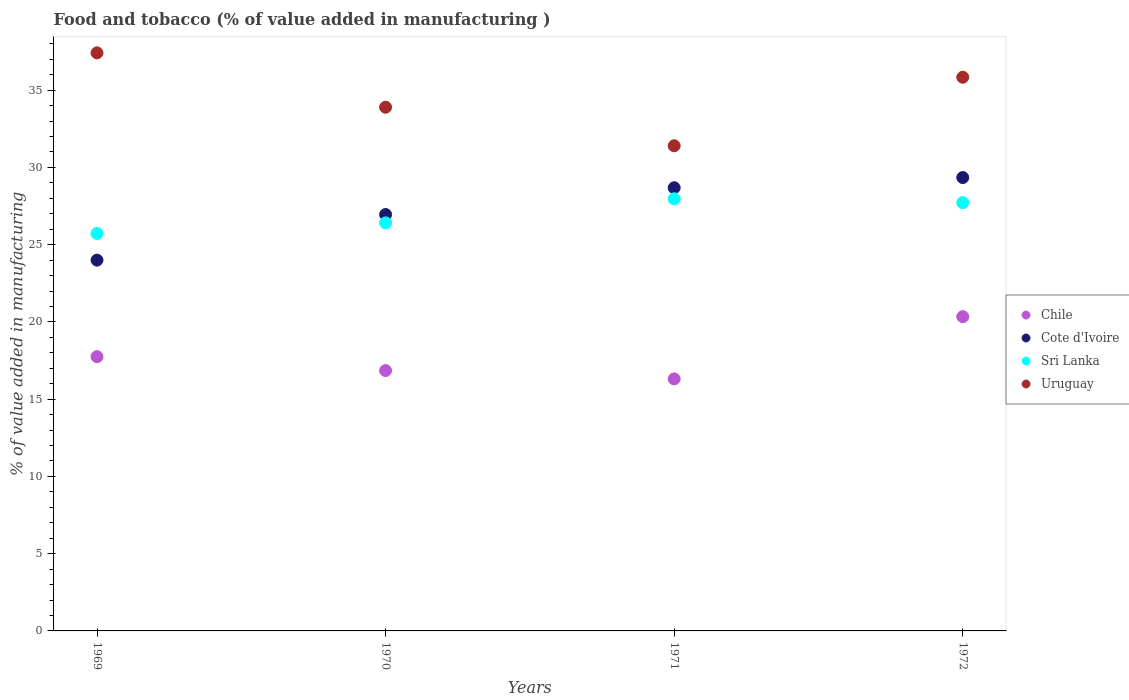What is the value added in manufacturing food and tobacco in Uruguay in 1970?
Provide a succinct answer. 33.9. Across all years, what is the maximum value added in manufacturing food and tobacco in Chile?
Your answer should be compact. 20.34. Across all years, what is the minimum value added in manufacturing food and tobacco in Uruguay?
Offer a terse response. 31.4. In which year was the value added in manufacturing food and tobacco in Sri Lanka minimum?
Provide a succinct answer. 1969. What is the total value added in manufacturing food and tobacco in Sri Lanka in the graph?
Make the answer very short. 107.83. What is the difference between the value added in manufacturing food and tobacco in Cote d'Ivoire in 1969 and that in 1970?
Offer a very short reply. -2.95. What is the difference between the value added in manufacturing food and tobacco in Sri Lanka in 1971 and the value added in manufacturing food and tobacco in Chile in 1970?
Offer a terse response. 11.12. What is the average value added in manufacturing food and tobacco in Sri Lanka per year?
Give a very brief answer. 26.96. In the year 1969, what is the difference between the value added in manufacturing food and tobacco in Uruguay and value added in manufacturing food and tobacco in Sri Lanka?
Provide a succinct answer. 11.69. What is the ratio of the value added in manufacturing food and tobacco in Cote d'Ivoire in 1970 to that in 1972?
Provide a succinct answer. 0.92. Is the value added in manufacturing food and tobacco in Uruguay in 1970 less than that in 1972?
Offer a very short reply. Yes. What is the difference between the highest and the second highest value added in manufacturing food and tobacco in Uruguay?
Provide a short and direct response. 1.58. What is the difference between the highest and the lowest value added in manufacturing food and tobacco in Chile?
Ensure brevity in your answer.  4.03. Is the sum of the value added in manufacturing food and tobacco in Uruguay in 1971 and 1972 greater than the maximum value added in manufacturing food and tobacco in Cote d'Ivoire across all years?
Ensure brevity in your answer.  Yes. Is the value added in manufacturing food and tobacco in Uruguay strictly greater than the value added in manufacturing food and tobacco in Sri Lanka over the years?
Give a very brief answer. Yes. How many years are there in the graph?
Offer a terse response. 4. What is the difference between two consecutive major ticks on the Y-axis?
Offer a very short reply. 5. Does the graph contain grids?
Provide a succinct answer. No. How many legend labels are there?
Make the answer very short. 4. How are the legend labels stacked?
Make the answer very short. Vertical. What is the title of the graph?
Ensure brevity in your answer.  Food and tobacco (% of value added in manufacturing ). Does "Germany" appear as one of the legend labels in the graph?
Provide a succinct answer. No. What is the label or title of the Y-axis?
Your response must be concise. % of value added in manufacturing. What is the % of value added in manufacturing of Chile in 1969?
Your answer should be compact. 17.75. What is the % of value added in manufacturing of Cote d'Ivoire in 1969?
Offer a terse response. 24. What is the % of value added in manufacturing of Sri Lanka in 1969?
Your answer should be compact. 25.73. What is the % of value added in manufacturing of Uruguay in 1969?
Your answer should be very brief. 37.42. What is the % of value added in manufacturing in Chile in 1970?
Make the answer very short. 16.85. What is the % of value added in manufacturing in Cote d'Ivoire in 1970?
Offer a terse response. 26.95. What is the % of value added in manufacturing of Sri Lanka in 1970?
Give a very brief answer. 26.41. What is the % of value added in manufacturing of Uruguay in 1970?
Ensure brevity in your answer.  33.9. What is the % of value added in manufacturing in Chile in 1971?
Keep it short and to the point. 16.31. What is the % of value added in manufacturing in Cote d'Ivoire in 1971?
Provide a succinct answer. 28.69. What is the % of value added in manufacturing in Sri Lanka in 1971?
Give a very brief answer. 27.97. What is the % of value added in manufacturing in Uruguay in 1971?
Your answer should be very brief. 31.4. What is the % of value added in manufacturing of Chile in 1972?
Provide a succinct answer. 20.34. What is the % of value added in manufacturing of Cote d'Ivoire in 1972?
Provide a short and direct response. 29.34. What is the % of value added in manufacturing of Sri Lanka in 1972?
Offer a very short reply. 27.72. What is the % of value added in manufacturing of Uruguay in 1972?
Your response must be concise. 35.84. Across all years, what is the maximum % of value added in manufacturing in Chile?
Your answer should be compact. 20.34. Across all years, what is the maximum % of value added in manufacturing of Cote d'Ivoire?
Provide a short and direct response. 29.34. Across all years, what is the maximum % of value added in manufacturing of Sri Lanka?
Give a very brief answer. 27.97. Across all years, what is the maximum % of value added in manufacturing of Uruguay?
Your answer should be very brief. 37.42. Across all years, what is the minimum % of value added in manufacturing of Chile?
Offer a terse response. 16.31. Across all years, what is the minimum % of value added in manufacturing of Cote d'Ivoire?
Provide a succinct answer. 24. Across all years, what is the minimum % of value added in manufacturing in Sri Lanka?
Ensure brevity in your answer.  25.73. Across all years, what is the minimum % of value added in manufacturing of Uruguay?
Keep it short and to the point. 31.4. What is the total % of value added in manufacturing of Chile in the graph?
Give a very brief answer. 71.26. What is the total % of value added in manufacturing in Cote d'Ivoire in the graph?
Offer a very short reply. 108.99. What is the total % of value added in manufacturing of Sri Lanka in the graph?
Provide a short and direct response. 107.83. What is the total % of value added in manufacturing in Uruguay in the graph?
Give a very brief answer. 138.56. What is the difference between the % of value added in manufacturing of Chile in 1969 and that in 1970?
Ensure brevity in your answer.  0.9. What is the difference between the % of value added in manufacturing in Cote d'Ivoire in 1969 and that in 1970?
Offer a terse response. -2.95. What is the difference between the % of value added in manufacturing of Sri Lanka in 1969 and that in 1970?
Provide a short and direct response. -0.68. What is the difference between the % of value added in manufacturing in Uruguay in 1969 and that in 1970?
Ensure brevity in your answer.  3.52. What is the difference between the % of value added in manufacturing of Chile in 1969 and that in 1971?
Your response must be concise. 1.44. What is the difference between the % of value added in manufacturing of Cote d'Ivoire in 1969 and that in 1971?
Your answer should be very brief. -4.69. What is the difference between the % of value added in manufacturing in Sri Lanka in 1969 and that in 1971?
Provide a short and direct response. -2.24. What is the difference between the % of value added in manufacturing in Uruguay in 1969 and that in 1971?
Your answer should be very brief. 6.01. What is the difference between the % of value added in manufacturing in Chile in 1969 and that in 1972?
Your answer should be very brief. -2.59. What is the difference between the % of value added in manufacturing in Cote d'Ivoire in 1969 and that in 1972?
Ensure brevity in your answer.  -5.34. What is the difference between the % of value added in manufacturing of Sri Lanka in 1969 and that in 1972?
Offer a terse response. -1.99. What is the difference between the % of value added in manufacturing in Uruguay in 1969 and that in 1972?
Your response must be concise. 1.58. What is the difference between the % of value added in manufacturing of Chile in 1970 and that in 1971?
Offer a very short reply. 0.54. What is the difference between the % of value added in manufacturing of Cote d'Ivoire in 1970 and that in 1971?
Ensure brevity in your answer.  -1.73. What is the difference between the % of value added in manufacturing in Sri Lanka in 1970 and that in 1971?
Your response must be concise. -1.56. What is the difference between the % of value added in manufacturing in Uruguay in 1970 and that in 1971?
Your answer should be compact. 2.5. What is the difference between the % of value added in manufacturing of Chile in 1970 and that in 1972?
Ensure brevity in your answer.  -3.49. What is the difference between the % of value added in manufacturing of Cote d'Ivoire in 1970 and that in 1972?
Make the answer very short. -2.39. What is the difference between the % of value added in manufacturing in Sri Lanka in 1970 and that in 1972?
Your answer should be very brief. -1.31. What is the difference between the % of value added in manufacturing in Uruguay in 1970 and that in 1972?
Provide a short and direct response. -1.94. What is the difference between the % of value added in manufacturing of Chile in 1971 and that in 1972?
Provide a short and direct response. -4.03. What is the difference between the % of value added in manufacturing in Cote d'Ivoire in 1971 and that in 1972?
Keep it short and to the point. -0.66. What is the difference between the % of value added in manufacturing in Sri Lanka in 1971 and that in 1972?
Give a very brief answer. 0.25. What is the difference between the % of value added in manufacturing of Uruguay in 1971 and that in 1972?
Keep it short and to the point. -4.44. What is the difference between the % of value added in manufacturing in Chile in 1969 and the % of value added in manufacturing in Cote d'Ivoire in 1970?
Offer a very short reply. -9.2. What is the difference between the % of value added in manufacturing of Chile in 1969 and the % of value added in manufacturing of Sri Lanka in 1970?
Your answer should be compact. -8.66. What is the difference between the % of value added in manufacturing of Chile in 1969 and the % of value added in manufacturing of Uruguay in 1970?
Provide a succinct answer. -16.15. What is the difference between the % of value added in manufacturing of Cote d'Ivoire in 1969 and the % of value added in manufacturing of Sri Lanka in 1970?
Provide a short and direct response. -2.41. What is the difference between the % of value added in manufacturing of Cote d'Ivoire in 1969 and the % of value added in manufacturing of Uruguay in 1970?
Give a very brief answer. -9.9. What is the difference between the % of value added in manufacturing in Sri Lanka in 1969 and the % of value added in manufacturing in Uruguay in 1970?
Keep it short and to the point. -8.17. What is the difference between the % of value added in manufacturing of Chile in 1969 and the % of value added in manufacturing of Cote d'Ivoire in 1971?
Provide a short and direct response. -10.94. What is the difference between the % of value added in manufacturing of Chile in 1969 and the % of value added in manufacturing of Sri Lanka in 1971?
Ensure brevity in your answer.  -10.22. What is the difference between the % of value added in manufacturing of Chile in 1969 and the % of value added in manufacturing of Uruguay in 1971?
Keep it short and to the point. -13.65. What is the difference between the % of value added in manufacturing of Cote d'Ivoire in 1969 and the % of value added in manufacturing of Sri Lanka in 1971?
Offer a terse response. -3.97. What is the difference between the % of value added in manufacturing in Cote d'Ivoire in 1969 and the % of value added in manufacturing in Uruguay in 1971?
Provide a short and direct response. -7.4. What is the difference between the % of value added in manufacturing in Sri Lanka in 1969 and the % of value added in manufacturing in Uruguay in 1971?
Keep it short and to the point. -5.68. What is the difference between the % of value added in manufacturing of Chile in 1969 and the % of value added in manufacturing of Cote d'Ivoire in 1972?
Offer a very short reply. -11.59. What is the difference between the % of value added in manufacturing of Chile in 1969 and the % of value added in manufacturing of Sri Lanka in 1972?
Ensure brevity in your answer.  -9.97. What is the difference between the % of value added in manufacturing of Chile in 1969 and the % of value added in manufacturing of Uruguay in 1972?
Offer a very short reply. -18.09. What is the difference between the % of value added in manufacturing of Cote d'Ivoire in 1969 and the % of value added in manufacturing of Sri Lanka in 1972?
Your response must be concise. -3.72. What is the difference between the % of value added in manufacturing in Cote d'Ivoire in 1969 and the % of value added in manufacturing in Uruguay in 1972?
Your answer should be compact. -11.84. What is the difference between the % of value added in manufacturing of Sri Lanka in 1969 and the % of value added in manufacturing of Uruguay in 1972?
Your answer should be compact. -10.11. What is the difference between the % of value added in manufacturing in Chile in 1970 and the % of value added in manufacturing in Cote d'Ivoire in 1971?
Provide a short and direct response. -11.84. What is the difference between the % of value added in manufacturing in Chile in 1970 and the % of value added in manufacturing in Sri Lanka in 1971?
Offer a very short reply. -11.12. What is the difference between the % of value added in manufacturing in Chile in 1970 and the % of value added in manufacturing in Uruguay in 1971?
Ensure brevity in your answer.  -14.55. What is the difference between the % of value added in manufacturing of Cote d'Ivoire in 1970 and the % of value added in manufacturing of Sri Lanka in 1971?
Keep it short and to the point. -1.02. What is the difference between the % of value added in manufacturing of Cote d'Ivoire in 1970 and the % of value added in manufacturing of Uruguay in 1971?
Offer a terse response. -4.45. What is the difference between the % of value added in manufacturing in Sri Lanka in 1970 and the % of value added in manufacturing in Uruguay in 1971?
Offer a terse response. -4.99. What is the difference between the % of value added in manufacturing of Chile in 1970 and the % of value added in manufacturing of Cote d'Ivoire in 1972?
Provide a succinct answer. -12.49. What is the difference between the % of value added in manufacturing of Chile in 1970 and the % of value added in manufacturing of Sri Lanka in 1972?
Provide a short and direct response. -10.87. What is the difference between the % of value added in manufacturing in Chile in 1970 and the % of value added in manufacturing in Uruguay in 1972?
Offer a very short reply. -18.99. What is the difference between the % of value added in manufacturing in Cote d'Ivoire in 1970 and the % of value added in manufacturing in Sri Lanka in 1972?
Make the answer very short. -0.77. What is the difference between the % of value added in manufacturing in Cote d'Ivoire in 1970 and the % of value added in manufacturing in Uruguay in 1972?
Offer a terse response. -8.89. What is the difference between the % of value added in manufacturing in Sri Lanka in 1970 and the % of value added in manufacturing in Uruguay in 1972?
Give a very brief answer. -9.43. What is the difference between the % of value added in manufacturing in Chile in 1971 and the % of value added in manufacturing in Cote d'Ivoire in 1972?
Your answer should be very brief. -13.03. What is the difference between the % of value added in manufacturing in Chile in 1971 and the % of value added in manufacturing in Sri Lanka in 1972?
Your response must be concise. -11.41. What is the difference between the % of value added in manufacturing in Chile in 1971 and the % of value added in manufacturing in Uruguay in 1972?
Offer a very short reply. -19.53. What is the difference between the % of value added in manufacturing of Cote d'Ivoire in 1971 and the % of value added in manufacturing of Sri Lanka in 1972?
Offer a very short reply. 0.97. What is the difference between the % of value added in manufacturing in Cote d'Ivoire in 1971 and the % of value added in manufacturing in Uruguay in 1972?
Offer a very short reply. -7.15. What is the difference between the % of value added in manufacturing in Sri Lanka in 1971 and the % of value added in manufacturing in Uruguay in 1972?
Your answer should be compact. -7.87. What is the average % of value added in manufacturing in Chile per year?
Give a very brief answer. 17.81. What is the average % of value added in manufacturing of Cote d'Ivoire per year?
Your answer should be very brief. 27.25. What is the average % of value added in manufacturing of Sri Lanka per year?
Ensure brevity in your answer.  26.96. What is the average % of value added in manufacturing in Uruguay per year?
Make the answer very short. 34.64. In the year 1969, what is the difference between the % of value added in manufacturing in Chile and % of value added in manufacturing in Cote d'Ivoire?
Your response must be concise. -6.25. In the year 1969, what is the difference between the % of value added in manufacturing of Chile and % of value added in manufacturing of Sri Lanka?
Offer a terse response. -7.97. In the year 1969, what is the difference between the % of value added in manufacturing of Chile and % of value added in manufacturing of Uruguay?
Your response must be concise. -19.66. In the year 1969, what is the difference between the % of value added in manufacturing in Cote d'Ivoire and % of value added in manufacturing in Sri Lanka?
Offer a terse response. -1.73. In the year 1969, what is the difference between the % of value added in manufacturing of Cote d'Ivoire and % of value added in manufacturing of Uruguay?
Offer a very short reply. -13.42. In the year 1969, what is the difference between the % of value added in manufacturing of Sri Lanka and % of value added in manufacturing of Uruguay?
Your response must be concise. -11.69. In the year 1970, what is the difference between the % of value added in manufacturing in Chile and % of value added in manufacturing in Cote d'Ivoire?
Give a very brief answer. -10.1. In the year 1970, what is the difference between the % of value added in manufacturing of Chile and % of value added in manufacturing of Sri Lanka?
Your answer should be compact. -9.56. In the year 1970, what is the difference between the % of value added in manufacturing of Chile and % of value added in manufacturing of Uruguay?
Give a very brief answer. -17.05. In the year 1970, what is the difference between the % of value added in manufacturing of Cote d'Ivoire and % of value added in manufacturing of Sri Lanka?
Provide a short and direct response. 0.54. In the year 1970, what is the difference between the % of value added in manufacturing of Cote d'Ivoire and % of value added in manufacturing of Uruguay?
Your answer should be very brief. -6.94. In the year 1970, what is the difference between the % of value added in manufacturing in Sri Lanka and % of value added in manufacturing in Uruguay?
Give a very brief answer. -7.49. In the year 1971, what is the difference between the % of value added in manufacturing in Chile and % of value added in manufacturing in Cote d'Ivoire?
Your answer should be compact. -12.38. In the year 1971, what is the difference between the % of value added in manufacturing of Chile and % of value added in manufacturing of Sri Lanka?
Provide a short and direct response. -11.66. In the year 1971, what is the difference between the % of value added in manufacturing in Chile and % of value added in manufacturing in Uruguay?
Your answer should be very brief. -15.09. In the year 1971, what is the difference between the % of value added in manufacturing of Cote d'Ivoire and % of value added in manufacturing of Sri Lanka?
Your response must be concise. 0.72. In the year 1971, what is the difference between the % of value added in manufacturing in Cote d'Ivoire and % of value added in manufacturing in Uruguay?
Offer a terse response. -2.72. In the year 1971, what is the difference between the % of value added in manufacturing of Sri Lanka and % of value added in manufacturing of Uruguay?
Your answer should be compact. -3.43. In the year 1972, what is the difference between the % of value added in manufacturing of Chile and % of value added in manufacturing of Cote d'Ivoire?
Make the answer very short. -9. In the year 1972, what is the difference between the % of value added in manufacturing of Chile and % of value added in manufacturing of Sri Lanka?
Your response must be concise. -7.38. In the year 1972, what is the difference between the % of value added in manufacturing of Chile and % of value added in manufacturing of Uruguay?
Keep it short and to the point. -15.5. In the year 1972, what is the difference between the % of value added in manufacturing in Cote d'Ivoire and % of value added in manufacturing in Sri Lanka?
Make the answer very short. 1.62. In the year 1972, what is the difference between the % of value added in manufacturing of Cote d'Ivoire and % of value added in manufacturing of Uruguay?
Your response must be concise. -6.5. In the year 1972, what is the difference between the % of value added in manufacturing in Sri Lanka and % of value added in manufacturing in Uruguay?
Provide a short and direct response. -8.12. What is the ratio of the % of value added in manufacturing in Chile in 1969 to that in 1970?
Keep it short and to the point. 1.05. What is the ratio of the % of value added in manufacturing of Cote d'Ivoire in 1969 to that in 1970?
Offer a terse response. 0.89. What is the ratio of the % of value added in manufacturing of Sri Lanka in 1969 to that in 1970?
Keep it short and to the point. 0.97. What is the ratio of the % of value added in manufacturing of Uruguay in 1969 to that in 1970?
Your response must be concise. 1.1. What is the ratio of the % of value added in manufacturing of Chile in 1969 to that in 1971?
Offer a terse response. 1.09. What is the ratio of the % of value added in manufacturing of Cote d'Ivoire in 1969 to that in 1971?
Offer a terse response. 0.84. What is the ratio of the % of value added in manufacturing in Sri Lanka in 1969 to that in 1971?
Give a very brief answer. 0.92. What is the ratio of the % of value added in manufacturing in Uruguay in 1969 to that in 1971?
Ensure brevity in your answer.  1.19. What is the ratio of the % of value added in manufacturing of Chile in 1969 to that in 1972?
Your response must be concise. 0.87. What is the ratio of the % of value added in manufacturing of Cote d'Ivoire in 1969 to that in 1972?
Your answer should be very brief. 0.82. What is the ratio of the % of value added in manufacturing in Sri Lanka in 1969 to that in 1972?
Provide a succinct answer. 0.93. What is the ratio of the % of value added in manufacturing of Uruguay in 1969 to that in 1972?
Offer a terse response. 1.04. What is the ratio of the % of value added in manufacturing in Chile in 1970 to that in 1971?
Offer a very short reply. 1.03. What is the ratio of the % of value added in manufacturing in Cote d'Ivoire in 1970 to that in 1971?
Offer a very short reply. 0.94. What is the ratio of the % of value added in manufacturing of Sri Lanka in 1970 to that in 1971?
Keep it short and to the point. 0.94. What is the ratio of the % of value added in manufacturing in Uruguay in 1970 to that in 1971?
Give a very brief answer. 1.08. What is the ratio of the % of value added in manufacturing of Chile in 1970 to that in 1972?
Offer a very short reply. 0.83. What is the ratio of the % of value added in manufacturing of Cote d'Ivoire in 1970 to that in 1972?
Keep it short and to the point. 0.92. What is the ratio of the % of value added in manufacturing in Sri Lanka in 1970 to that in 1972?
Make the answer very short. 0.95. What is the ratio of the % of value added in manufacturing in Uruguay in 1970 to that in 1972?
Provide a succinct answer. 0.95. What is the ratio of the % of value added in manufacturing in Chile in 1971 to that in 1972?
Your response must be concise. 0.8. What is the ratio of the % of value added in manufacturing in Cote d'Ivoire in 1971 to that in 1972?
Ensure brevity in your answer.  0.98. What is the ratio of the % of value added in manufacturing of Uruguay in 1971 to that in 1972?
Your answer should be very brief. 0.88. What is the difference between the highest and the second highest % of value added in manufacturing of Chile?
Your answer should be very brief. 2.59. What is the difference between the highest and the second highest % of value added in manufacturing of Cote d'Ivoire?
Offer a very short reply. 0.66. What is the difference between the highest and the second highest % of value added in manufacturing of Sri Lanka?
Keep it short and to the point. 0.25. What is the difference between the highest and the second highest % of value added in manufacturing in Uruguay?
Ensure brevity in your answer.  1.58. What is the difference between the highest and the lowest % of value added in manufacturing of Chile?
Keep it short and to the point. 4.03. What is the difference between the highest and the lowest % of value added in manufacturing in Cote d'Ivoire?
Your response must be concise. 5.34. What is the difference between the highest and the lowest % of value added in manufacturing in Sri Lanka?
Offer a very short reply. 2.24. What is the difference between the highest and the lowest % of value added in manufacturing in Uruguay?
Make the answer very short. 6.01. 